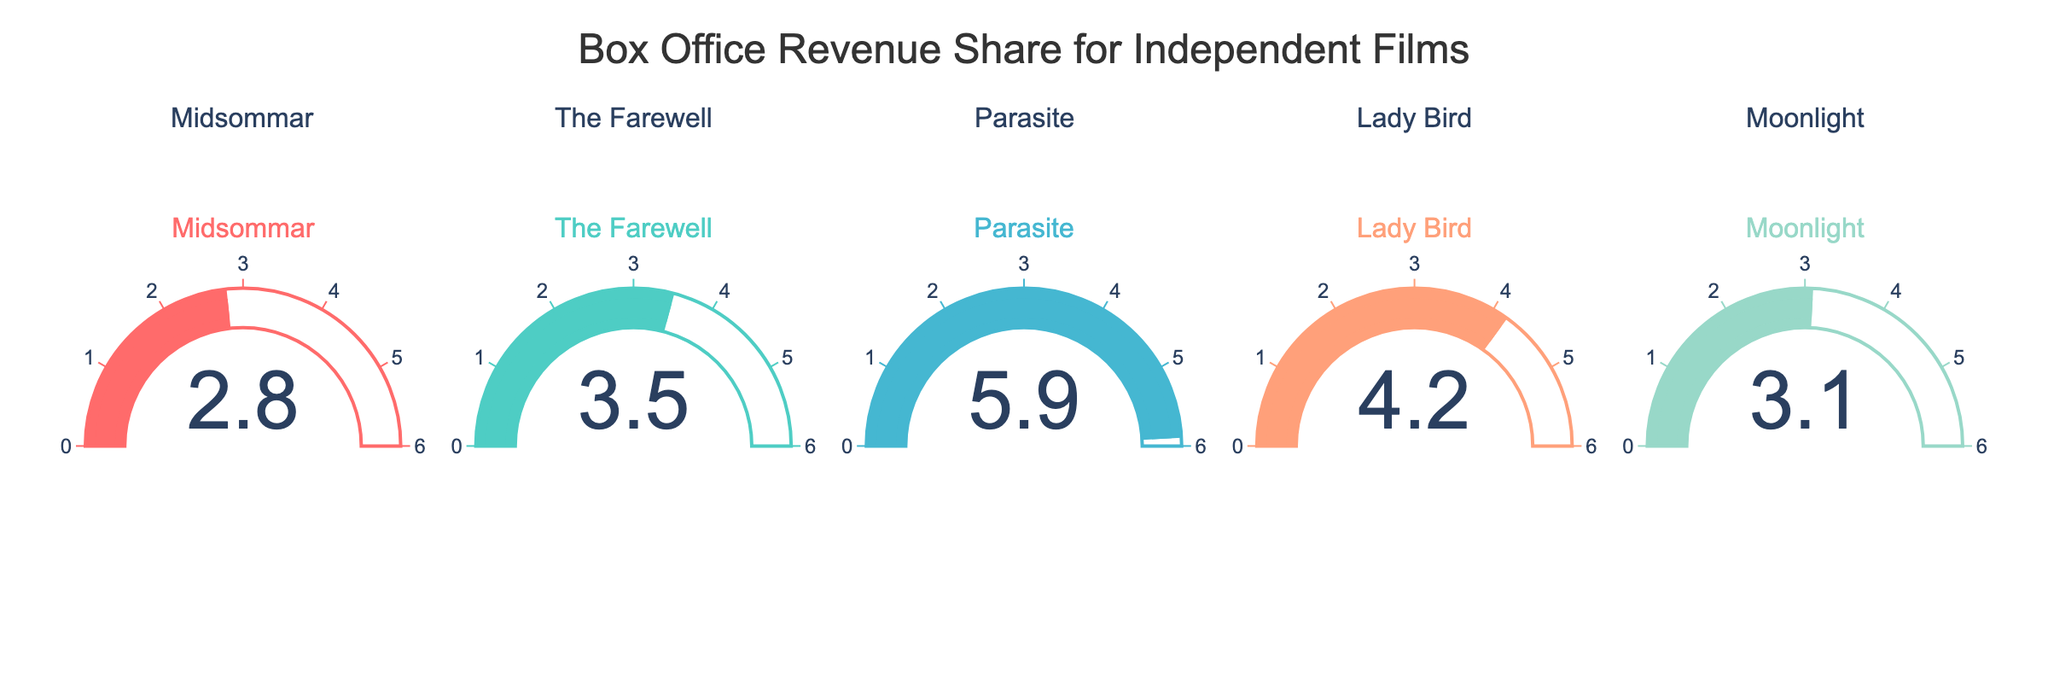what is the title of the plot? The figure has a title written at the top. The title is "Box Office Revenue Share for Independent Films".
Answer: Box Office Revenue Share for Independent Films Which movie has the highest box office revenue share? By examining the gauge charts, the movie with the highest value on its gauge is "Parasite", which has a value of 5.9.
Answer: Parasite What is the range of the gauge indicators shown in the figure? Each gauge chart has an axis with a range that goes from 0 to 6, as indicated by the markings.
Answer: 0 to 6 How many movies are represented in the figure? There are five separate gauge charts, each representing a different movie: "Midsommar", "The Farewell", "Parasite", "Lady Bird", and "Moonlight".
Answer: 5 Compare the box office revenue share between "Moonlight" and "Lady Bird". "Moonlight" has a value of 3.1 while "Lady Bird" has a value of 4.2. Therefore, "Lady Bird" has a higher revenue share than "Moonlight".
Answer: Lady Bird has a higher revenue share Which movie has the lowest box office revenue share and what is its value? By looking at the gauge charts, "Midsommar" has the lowest value, which is 2.8.
Answer: Midsommar, 2.8 What is the average box office revenue share of all the movies? Sum the values of all the movies (2.8 + 3.5 + 5.9 + 4.2 + 3.1) which equals 19.5, then divide by the number of movies, which is 5. The average is 19.5 / 5 = 3.9.
Answer: 3.9 Which two movies combined have a box office revenue share that exceeds 8? By examining the values, "Parasite" (5.9) and "Lady Bird" (4.2) combined have a total of 5.9 + 4.2 = 10.1, which exceeds 8.
Answer: Parasite and Lady Bird What is the difference in box office revenue share between "The Farewell" and "Midsommar"? "The Farewell" has a value of 3.5 and "Midsommar" has a value of 2.8. The difference is calculated as 3.5 - 2.8 = 0.7.
Answer: 0.7 